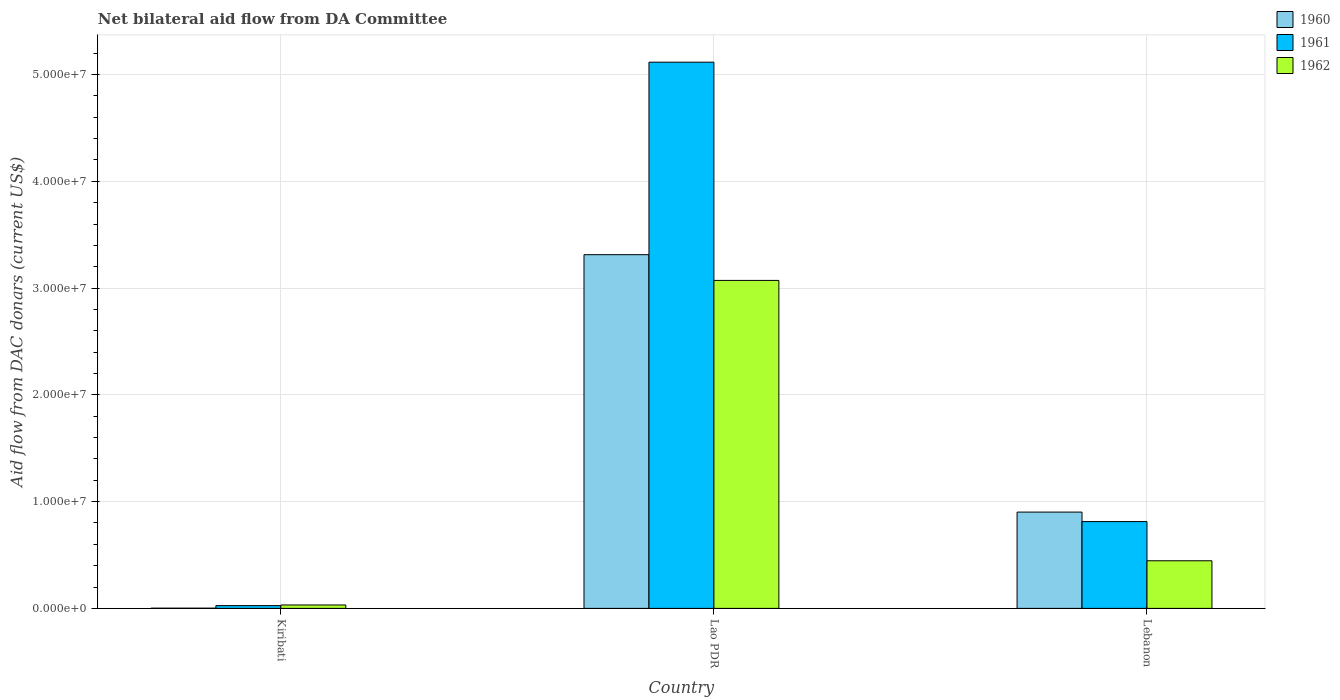How many different coloured bars are there?
Provide a succinct answer. 3. How many groups of bars are there?
Offer a very short reply. 3. Are the number of bars per tick equal to the number of legend labels?
Your answer should be compact. Yes. Are the number of bars on each tick of the X-axis equal?
Your answer should be compact. Yes. What is the label of the 2nd group of bars from the left?
Ensure brevity in your answer.  Lao PDR. In how many cases, is the number of bars for a given country not equal to the number of legend labels?
Make the answer very short. 0. What is the aid flow in in 1962 in Lao PDR?
Offer a very short reply. 3.07e+07. Across all countries, what is the maximum aid flow in in 1962?
Make the answer very short. 3.07e+07. In which country was the aid flow in in 1962 maximum?
Your answer should be very brief. Lao PDR. In which country was the aid flow in in 1962 minimum?
Provide a succinct answer. Kiribati. What is the total aid flow in in 1962 in the graph?
Provide a short and direct response. 3.55e+07. What is the difference between the aid flow in in 1960 in Kiribati and that in Lao PDR?
Give a very brief answer. -3.31e+07. What is the difference between the aid flow in in 1960 in Lebanon and the aid flow in in 1962 in Lao PDR?
Your response must be concise. -2.17e+07. What is the average aid flow in in 1961 per country?
Make the answer very short. 1.98e+07. What is the difference between the aid flow in of/in 1962 and aid flow in of/in 1961 in Lao PDR?
Your response must be concise. -2.04e+07. What is the ratio of the aid flow in in 1962 in Kiribati to that in Lebanon?
Offer a terse response. 0.07. What is the difference between the highest and the second highest aid flow in in 1962?
Keep it short and to the point. 3.04e+07. What is the difference between the highest and the lowest aid flow in in 1961?
Keep it short and to the point. 5.09e+07. In how many countries, is the aid flow in in 1961 greater than the average aid flow in in 1961 taken over all countries?
Your answer should be very brief. 1. What does the 2nd bar from the right in Lao PDR represents?
Your answer should be very brief. 1961. How many countries are there in the graph?
Offer a very short reply. 3. Does the graph contain any zero values?
Your answer should be very brief. No. How many legend labels are there?
Offer a very short reply. 3. How are the legend labels stacked?
Provide a short and direct response. Vertical. What is the title of the graph?
Ensure brevity in your answer.  Net bilateral aid flow from DA Committee. What is the label or title of the Y-axis?
Your answer should be compact. Aid flow from DAC donars (current US$). What is the Aid flow from DAC donars (current US$) in 1960 in Kiribati?
Give a very brief answer. 2.00e+04. What is the Aid flow from DAC donars (current US$) in 1961 in Kiribati?
Keep it short and to the point. 2.60e+05. What is the Aid flow from DAC donars (current US$) of 1960 in Lao PDR?
Make the answer very short. 3.31e+07. What is the Aid flow from DAC donars (current US$) of 1961 in Lao PDR?
Keep it short and to the point. 5.12e+07. What is the Aid flow from DAC donars (current US$) of 1962 in Lao PDR?
Provide a succinct answer. 3.07e+07. What is the Aid flow from DAC donars (current US$) in 1960 in Lebanon?
Provide a succinct answer. 9.02e+06. What is the Aid flow from DAC donars (current US$) in 1961 in Lebanon?
Your answer should be compact. 8.13e+06. What is the Aid flow from DAC donars (current US$) of 1962 in Lebanon?
Your answer should be very brief. 4.46e+06. Across all countries, what is the maximum Aid flow from DAC donars (current US$) of 1960?
Make the answer very short. 3.31e+07. Across all countries, what is the maximum Aid flow from DAC donars (current US$) in 1961?
Your answer should be very brief. 5.12e+07. Across all countries, what is the maximum Aid flow from DAC donars (current US$) of 1962?
Your answer should be compact. 3.07e+07. What is the total Aid flow from DAC donars (current US$) of 1960 in the graph?
Provide a short and direct response. 4.22e+07. What is the total Aid flow from DAC donars (current US$) in 1961 in the graph?
Ensure brevity in your answer.  5.96e+07. What is the total Aid flow from DAC donars (current US$) of 1962 in the graph?
Provide a short and direct response. 3.55e+07. What is the difference between the Aid flow from DAC donars (current US$) of 1960 in Kiribati and that in Lao PDR?
Provide a short and direct response. -3.31e+07. What is the difference between the Aid flow from DAC donars (current US$) in 1961 in Kiribati and that in Lao PDR?
Give a very brief answer. -5.09e+07. What is the difference between the Aid flow from DAC donars (current US$) in 1962 in Kiribati and that in Lao PDR?
Give a very brief answer. -3.04e+07. What is the difference between the Aid flow from DAC donars (current US$) in 1960 in Kiribati and that in Lebanon?
Your response must be concise. -9.00e+06. What is the difference between the Aid flow from DAC donars (current US$) in 1961 in Kiribati and that in Lebanon?
Provide a succinct answer. -7.87e+06. What is the difference between the Aid flow from DAC donars (current US$) of 1962 in Kiribati and that in Lebanon?
Provide a succinct answer. -4.14e+06. What is the difference between the Aid flow from DAC donars (current US$) in 1960 in Lao PDR and that in Lebanon?
Ensure brevity in your answer.  2.41e+07. What is the difference between the Aid flow from DAC donars (current US$) of 1961 in Lao PDR and that in Lebanon?
Your response must be concise. 4.30e+07. What is the difference between the Aid flow from DAC donars (current US$) of 1962 in Lao PDR and that in Lebanon?
Provide a succinct answer. 2.63e+07. What is the difference between the Aid flow from DAC donars (current US$) of 1960 in Kiribati and the Aid flow from DAC donars (current US$) of 1961 in Lao PDR?
Offer a terse response. -5.11e+07. What is the difference between the Aid flow from DAC donars (current US$) in 1960 in Kiribati and the Aid flow from DAC donars (current US$) in 1962 in Lao PDR?
Offer a terse response. -3.07e+07. What is the difference between the Aid flow from DAC donars (current US$) in 1961 in Kiribati and the Aid flow from DAC donars (current US$) in 1962 in Lao PDR?
Give a very brief answer. -3.05e+07. What is the difference between the Aid flow from DAC donars (current US$) of 1960 in Kiribati and the Aid flow from DAC donars (current US$) of 1961 in Lebanon?
Provide a short and direct response. -8.11e+06. What is the difference between the Aid flow from DAC donars (current US$) of 1960 in Kiribati and the Aid flow from DAC donars (current US$) of 1962 in Lebanon?
Offer a terse response. -4.44e+06. What is the difference between the Aid flow from DAC donars (current US$) of 1961 in Kiribati and the Aid flow from DAC donars (current US$) of 1962 in Lebanon?
Your response must be concise. -4.20e+06. What is the difference between the Aid flow from DAC donars (current US$) of 1960 in Lao PDR and the Aid flow from DAC donars (current US$) of 1961 in Lebanon?
Keep it short and to the point. 2.50e+07. What is the difference between the Aid flow from DAC donars (current US$) of 1960 in Lao PDR and the Aid flow from DAC donars (current US$) of 1962 in Lebanon?
Make the answer very short. 2.87e+07. What is the difference between the Aid flow from DAC donars (current US$) in 1961 in Lao PDR and the Aid flow from DAC donars (current US$) in 1962 in Lebanon?
Provide a short and direct response. 4.67e+07. What is the average Aid flow from DAC donars (current US$) of 1960 per country?
Ensure brevity in your answer.  1.41e+07. What is the average Aid flow from DAC donars (current US$) in 1961 per country?
Provide a succinct answer. 1.98e+07. What is the average Aid flow from DAC donars (current US$) of 1962 per country?
Offer a very short reply. 1.18e+07. What is the difference between the Aid flow from DAC donars (current US$) in 1960 and Aid flow from DAC donars (current US$) in 1961 in Kiribati?
Your answer should be very brief. -2.40e+05. What is the difference between the Aid flow from DAC donars (current US$) in 1960 and Aid flow from DAC donars (current US$) in 1962 in Kiribati?
Your response must be concise. -3.00e+05. What is the difference between the Aid flow from DAC donars (current US$) of 1961 and Aid flow from DAC donars (current US$) of 1962 in Kiribati?
Offer a very short reply. -6.00e+04. What is the difference between the Aid flow from DAC donars (current US$) in 1960 and Aid flow from DAC donars (current US$) in 1961 in Lao PDR?
Make the answer very short. -1.80e+07. What is the difference between the Aid flow from DAC donars (current US$) of 1960 and Aid flow from DAC donars (current US$) of 1962 in Lao PDR?
Give a very brief answer. 2.41e+06. What is the difference between the Aid flow from DAC donars (current US$) in 1961 and Aid flow from DAC donars (current US$) in 1962 in Lao PDR?
Offer a very short reply. 2.04e+07. What is the difference between the Aid flow from DAC donars (current US$) of 1960 and Aid flow from DAC donars (current US$) of 1961 in Lebanon?
Your response must be concise. 8.90e+05. What is the difference between the Aid flow from DAC donars (current US$) in 1960 and Aid flow from DAC donars (current US$) in 1962 in Lebanon?
Give a very brief answer. 4.56e+06. What is the difference between the Aid flow from DAC donars (current US$) in 1961 and Aid flow from DAC donars (current US$) in 1962 in Lebanon?
Provide a succinct answer. 3.67e+06. What is the ratio of the Aid flow from DAC donars (current US$) in 1960 in Kiribati to that in Lao PDR?
Offer a terse response. 0. What is the ratio of the Aid flow from DAC donars (current US$) of 1961 in Kiribati to that in Lao PDR?
Provide a short and direct response. 0.01. What is the ratio of the Aid flow from DAC donars (current US$) of 1962 in Kiribati to that in Lao PDR?
Ensure brevity in your answer.  0.01. What is the ratio of the Aid flow from DAC donars (current US$) of 1960 in Kiribati to that in Lebanon?
Make the answer very short. 0. What is the ratio of the Aid flow from DAC donars (current US$) of 1961 in Kiribati to that in Lebanon?
Make the answer very short. 0.03. What is the ratio of the Aid flow from DAC donars (current US$) of 1962 in Kiribati to that in Lebanon?
Make the answer very short. 0.07. What is the ratio of the Aid flow from DAC donars (current US$) in 1960 in Lao PDR to that in Lebanon?
Provide a short and direct response. 3.67. What is the ratio of the Aid flow from DAC donars (current US$) in 1961 in Lao PDR to that in Lebanon?
Offer a terse response. 6.29. What is the ratio of the Aid flow from DAC donars (current US$) of 1962 in Lao PDR to that in Lebanon?
Give a very brief answer. 6.89. What is the difference between the highest and the second highest Aid flow from DAC donars (current US$) in 1960?
Offer a very short reply. 2.41e+07. What is the difference between the highest and the second highest Aid flow from DAC donars (current US$) of 1961?
Offer a very short reply. 4.30e+07. What is the difference between the highest and the second highest Aid flow from DAC donars (current US$) in 1962?
Your response must be concise. 2.63e+07. What is the difference between the highest and the lowest Aid flow from DAC donars (current US$) of 1960?
Provide a succinct answer. 3.31e+07. What is the difference between the highest and the lowest Aid flow from DAC donars (current US$) in 1961?
Your answer should be compact. 5.09e+07. What is the difference between the highest and the lowest Aid flow from DAC donars (current US$) in 1962?
Give a very brief answer. 3.04e+07. 